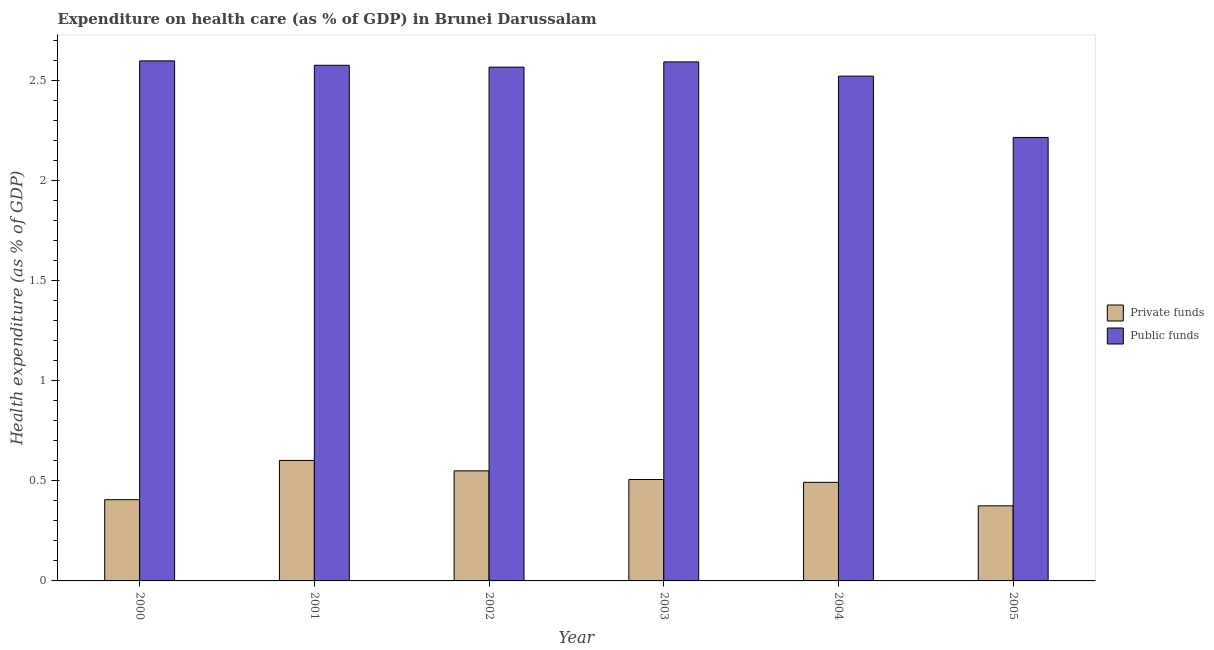In how many cases, is the number of bars for a given year not equal to the number of legend labels?
Offer a terse response. 0. What is the amount of private funds spent in healthcare in 2001?
Make the answer very short. 0.6. Across all years, what is the maximum amount of private funds spent in healthcare?
Your answer should be very brief. 0.6. Across all years, what is the minimum amount of private funds spent in healthcare?
Provide a short and direct response. 0.38. In which year was the amount of public funds spent in healthcare maximum?
Keep it short and to the point. 2000. In which year was the amount of public funds spent in healthcare minimum?
Give a very brief answer. 2005. What is the total amount of public funds spent in healthcare in the graph?
Ensure brevity in your answer.  15.07. What is the difference between the amount of private funds spent in healthcare in 2002 and that in 2003?
Offer a terse response. 0.04. What is the difference between the amount of public funds spent in healthcare in 2003 and the amount of private funds spent in healthcare in 2005?
Provide a succinct answer. 0.38. What is the average amount of public funds spent in healthcare per year?
Ensure brevity in your answer.  2.51. In how many years, is the amount of public funds spent in healthcare greater than 2.1 %?
Your answer should be very brief. 6. What is the ratio of the amount of private funds spent in healthcare in 2001 to that in 2004?
Offer a very short reply. 1.22. Is the difference between the amount of public funds spent in healthcare in 2003 and 2005 greater than the difference between the amount of private funds spent in healthcare in 2003 and 2005?
Your answer should be very brief. No. What is the difference between the highest and the second highest amount of public funds spent in healthcare?
Keep it short and to the point. 0.01. What is the difference between the highest and the lowest amount of public funds spent in healthcare?
Provide a succinct answer. 0.38. What does the 2nd bar from the left in 2000 represents?
Give a very brief answer. Public funds. What does the 1st bar from the right in 2001 represents?
Your response must be concise. Public funds. How many bars are there?
Make the answer very short. 12. What is the difference between two consecutive major ticks on the Y-axis?
Give a very brief answer. 0.5. Where does the legend appear in the graph?
Your answer should be very brief. Center right. How many legend labels are there?
Your answer should be very brief. 2. What is the title of the graph?
Your answer should be compact. Expenditure on health care (as % of GDP) in Brunei Darussalam. Does "By country of asylum" appear as one of the legend labels in the graph?
Keep it short and to the point. No. What is the label or title of the Y-axis?
Ensure brevity in your answer.  Health expenditure (as % of GDP). What is the Health expenditure (as % of GDP) in Private funds in 2000?
Offer a very short reply. 0.41. What is the Health expenditure (as % of GDP) in Public funds in 2000?
Keep it short and to the point. 2.6. What is the Health expenditure (as % of GDP) in Private funds in 2001?
Your answer should be very brief. 0.6. What is the Health expenditure (as % of GDP) in Public funds in 2001?
Offer a very short reply. 2.58. What is the Health expenditure (as % of GDP) of Private funds in 2002?
Your answer should be very brief. 0.55. What is the Health expenditure (as % of GDP) of Public funds in 2002?
Your answer should be compact. 2.57. What is the Health expenditure (as % of GDP) in Private funds in 2003?
Your answer should be very brief. 0.51. What is the Health expenditure (as % of GDP) of Public funds in 2003?
Provide a short and direct response. 2.59. What is the Health expenditure (as % of GDP) of Private funds in 2004?
Your answer should be compact. 0.49. What is the Health expenditure (as % of GDP) of Public funds in 2004?
Provide a short and direct response. 2.52. What is the Health expenditure (as % of GDP) of Private funds in 2005?
Keep it short and to the point. 0.38. What is the Health expenditure (as % of GDP) in Public funds in 2005?
Provide a short and direct response. 2.22. Across all years, what is the maximum Health expenditure (as % of GDP) of Private funds?
Your answer should be very brief. 0.6. Across all years, what is the maximum Health expenditure (as % of GDP) of Public funds?
Give a very brief answer. 2.6. Across all years, what is the minimum Health expenditure (as % of GDP) in Private funds?
Give a very brief answer. 0.38. Across all years, what is the minimum Health expenditure (as % of GDP) in Public funds?
Provide a succinct answer. 2.22. What is the total Health expenditure (as % of GDP) in Private funds in the graph?
Make the answer very short. 2.93. What is the total Health expenditure (as % of GDP) in Public funds in the graph?
Offer a terse response. 15.07. What is the difference between the Health expenditure (as % of GDP) of Private funds in 2000 and that in 2001?
Your response must be concise. -0.2. What is the difference between the Health expenditure (as % of GDP) in Public funds in 2000 and that in 2001?
Your response must be concise. 0.02. What is the difference between the Health expenditure (as % of GDP) of Private funds in 2000 and that in 2002?
Make the answer very short. -0.14. What is the difference between the Health expenditure (as % of GDP) of Public funds in 2000 and that in 2002?
Your answer should be compact. 0.03. What is the difference between the Health expenditure (as % of GDP) of Private funds in 2000 and that in 2003?
Provide a succinct answer. -0.1. What is the difference between the Health expenditure (as % of GDP) in Public funds in 2000 and that in 2003?
Provide a succinct answer. 0.01. What is the difference between the Health expenditure (as % of GDP) in Private funds in 2000 and that in 2004?
Keep it short and to the point. -0.09. What is the difference between the Health expenditure (as % of GDP) in Public funds in 2000 and that in 2004?
Your answer should be compact. 0.08. What is the difference between the Health expenditure (as % of GDP) of Private funds in 2000 and that in 2005?
Ensure brevity in your answer.  0.03. What is the difference between the Health expenditure (as % of GDP) in Public funds in 2000 and that in 2005?
Your answer should be very brief. 0.38. What is the difference between the Health expenditure (as % of GDP) of Private funds in 2001 and that in 2002?
Your answer should be compact. 0.05. What is the difference between the Health expenditure (as % of GDP) in Public funds in 2001 and that in 2002?
Your answer should be very brief. 0.01. What is the difference between the Health expenditure (as % of GDP) in Private funds in 2001 and that in 2003?
Offer a terse response. 0.1. What is the difference between the Health expenditure (as % of GDP) of Public funds in 2001 and that in 2003?
Offer a very short reply. -0.02. What is the difference between the Health expenditure (as % of GDP) of Private funds in 2001 and that in 2004?
Ensure brevity in your answer.  0.11. What is the difference between the Health expenditure (as % of GDP) of Public funds in 2001 and that in 2004?
Ensure brevity in your answer.  0.05. What is the difference between the Health expenditure (as % of GDP) in Private funds in 2001 and that in 2005?
Offer a terse response. 0.23. What is the difference between the Health expenditure (as % of GDP) in Public funds in 2001 and that in 2005?
Ensure brevity in your answer.  0.36. What is the difference between the Health expenditure (as % of GDP) in Private funds in 2002 and that in 2003?
Ensure brevity in your answer.  0.04. What is the difference between the Health expenditure (as % of GDP) in Public funds in 2002 and that in 2003?
Offer a terse response. -0.03. What is the difference between the Health expenditure (as % of GDP) in Private funds in 2002 and that in 2004?
Ensure brevity in your answer.  0.06. What is the difference between the Health expenditure (as % of GDP) of Public funds in 2002 and that in 2004?
Provide a succinct answer. 0.05. What is the difference between the Health expenditure (as % of GDP) of Private funds in 2002 and that in 2005?
Provide a succinct answer. 0.17. What is the difference between the Health expenditure (as % of GDP) in Public funds in 2002 and that in 2005?
Ensure brevity in your answer.  0.35. What is the difference between the Health expenditure (as % of GDP) in Private funds in 2003 and that in 2004?
Give a very brief answer. 0.01. What is the difference between the Health expenditure (as % of GDP) of Public funds in 2003 and that in 2004?
Your answer should be very brief. 0.07. What is the difference between the Health expenditure (as % of GDP) of Private funds in 2003 and that in 2005?
Keep it short and to the point. 0.13. What is the difference between the Health expenditure (as % of GDP) of Public funds in 2003 and that in 2005?
Provide a short and direct response. 0.38. What is the difference between the Health expenditure (as % of GDP) of Private funds in 2004 and that in 2005?
Your answer should be very brief. 0.12. What is the difference between the Health expenditure (as % of GDP) in Public funds in 2004 and that in 2005?
Ensure brevity in your answer.  0.31. What is the difference between the Health expenditure (as % of GDP) of Private funds in 2000 and the Health expenditure (as % of GDP) of Public funds in 2001?
Your answer should be very brief. -2.17. What is the difference between the Health expenditure (as % of GDP) of Private funds in 2000 and the Health expenditure (as % of GDP) of Public funds in 2002?
Ensure brevity in your answer.  -2.16. What is the difference between the Health expenditure (as % of GDP) in Private funds in 2000 and the Health expenditure (as % of GDP) in Public funds in 2003?
Your answer should be very brief. -2.19. What is the difference between the Health expenditure (as % of GDP) of Private funds in 2000 and the Health expenditure (as % of GDP) of Public funds in 2004?
Your response must be concise. -2.12. What is the difference between the Health expenditure (as % of GDP) in Private funds in 2000 and the Health expenditure (as % of GDP) in Public funds in 2005?
Make the answer very short. -1.81. What is the difference between the Health expenditure (as % of GDP) in Private funds in 2001 and the Health expenditure (as % of GDP) in Public funds in 2002?
Provide a succinct answer. -1.97. What is the difference between the Health expenditure (as % of GDP) in Private funds in 2001 and the Health expenditure (as % of GDP) in Public funds in 2003?
Offer a terse response. -1.99. What is the difference between the Health expenditure (as % of GDP) of Private funds in 2001 and the Health expenditure (as % of GDP) of Public funds in 2004?
Your answer should be compact. -1.92. What is the difference between the Health expenditure (as % of GDP) of Private funds in 2001 and the Health expenditure (as % of GDP) of Public funds in 2005?
Your answer should be very brief. -1.61. What is the difference between the Health expenditure (as % of GDP) in Private funds in 2002 and the Health expenditure (as % of GDP) in Public funds in 2003?
Give a very brief answer. -2.04. What is the difference between the Health expenditure (as % of GDP) in Private funds in 2002 and the Health expenditure (as % of GDP) in Public funds in 2004?
Your answer should be very brief. -1.97. What is the difference between the Health expenditure (as % of GDP) of Private funds in 2002 and the Health expenditure (as % of GDP) of Public funds in 2005?
Offer a terse response. -1.67. What is the difference between the Health expenditure (as % of GDP) of Private funds in 2003 and the Health expenditure (as % of GDP) of Public funds in 2004?
Your answer should be compact. -2.02. What is the difference between the Health expenditure (as % of GDP) in Private funds in 2003 and the Health expenditure (as % of GDP) in Public funds in 2005?
Offer a terse response. -1.71. What is the difference between the Health expenditure (as % of GDP) of Private funds in 2004 and the Health expenditure (as % of GDP) of Public funds in 2005?
Offer a terse response. -1.72. What is the average Health expenditure (as % of GDP) of Private funds per year?
Your answer should be very brief. 0.49. What is the average Health expenditure (as % of GDP) of Public funds per year?
Make the answer very short. 2.51. In the year 2000, what is the difference between the Health expenditure (as % of GDP) in Private funds and Health expenditure (as % of GDP) in Public funds?
Make the answer very short. -2.19. In the year 2001, what is the difference between the Health expenditure (as % of GDP) of Private funds and Health expenditure (as % of GDP) of Public funds?
Keep it short and to the point. -1.97. In the year 2002, what is the difference between the Health expenditure (as % of GDP) of Private funds and Health expenditure (as % of GDP) of Public funds?
Your answer should be compact. -2.02. In the year 2003, what is the difference between the Health expenditure (as % of GDP) in Private funds and Health expenditure (as % of GDP) in Public funds?
Provide a succinct answer. -2.09. In the year 2004, what is the difference between the Health expenditure (as % of GDP) in Private funds and Health expenditure (as % of GDP) in Public funds?
Ensure brevity in your answer.  -2.03. In the year 2005, what is the difference between the Health expenditure (as % of GDP) in Private funds and Health expenditure (as % of GDP) in Public funds?
Offer a terse response. -1.84. What is the ratio of the Health expenditure (as % of GDP) in Private funds in 2000 to that in 2001?
Your answer should be very brief. 0.67. What is the ratio of the Health expenditure (as % of GDP) in Public funds in 2000 to that in 2001?
Your answer should be compact. 1.01. What is the ratio of the Health expenditure (as % of GDP) in Private funds in 2000 to that in 2002?
Your response must be concise. 0.74. What is the ratio of the Health expenditure (as % of GDP) in Public funds in 2000 to that in 2002?
Make the answer very short. 1.01. What is the ratio of the Health expenditure (as % of GDP) of Private funds in 2000 to that in 2003?
Your answer should be very brief. 0.8. What is the ratio of the Health expenditure (as % of GDP) of Private funds in 2000 to that in 2004?
Give a very brief answer. 0.82. What is the ratio of the Health expenditure (as % of GDP) in Public funds in 2000 to that in 2004?
Ensure brevity in your answer.  1.03. What is the ratio of the Health expenditure (as % of GDP) in Private funds in 2000 to that in 2005?
Your response must be concise. 1.08. What is the ratio of the Health expenditure (as % of GDP) in Public funds in 2000 to that in 2005?
Ensure brevity in your answer.  1.17. What is the ratio of the Health expenditure (as % of GDP) of Private funds in 2001 to that in 2002?
Ensure brevity in your answer.  1.09. What is the ratio of the Health expenditure (as % of GDP) of Private funds in 2001 to that in 2003?
Ensure brevity in your answer.  1.19. What is the ratio of the Health expenditure (as % of GDP) of Private funds in 2001 to that in 2004?
Your response must be concise. 1.22. What is the ratio of the Health expenditure (as % of GDP) of Public funds in 2001 to that in 2004?
Your response must be concise. 1.02. What is the ratio of the Health expenditure (as % of GDP) of Private funds in 2001 to that in 2005?
Give a very brief answer. 1.61. What is the ratio of the Health expenditure (as % of GDP) in Public funds in 2001 to that in 2005?
Make the answer very short. 1.16. What is the ratio of the Health expenditure (as % of GDP) in Private funds in 2002 to that in 2003?
Provide a succinct answer. 1.09. What is the ratio of the Health expenditure (as % of GDP) of Public funds in 2002 to that in 2003?
Offer a terse response. 0.99. What is the ratio of the Health expenditure (as % of GDP) of Private funds in 2002 to that in 2004?
Your answer should be compact. 1.12. What is the ratio of the Health expenditure (as % of GDP) of Public funds in 2002 to that in 2004?
Your answer should be compact. 1.02. What is the ratio of the Health expenditure (as % of GDP) in Private funds in 2002 to that in 2005?
Provide a succinct answer. 1.47. What is the ratio of the Health expenditure (as % of GDP) in Public funds in 2002 to that in 2005?
Provide a succinct answer. 1.16. What is the ratio of the Health expenditure (as % of GDP) in Private funds in 2003 to that in 2004?
Your answer should be compact. 1.03. What is the ratio of the Health expenditure (as % of GDP) in Public funds in 2003 to that in 2004?
Give a very brief answer. 1.03. What is the ratio of the Health expenditure (as % of GDP) of Private funds in 2003 to that in 2005?
Make the answer very short. 1.35. What is the ratio of the Health expenditure (as % of GDP) in Public funds in 2003 to that in 2005?
Your response must be concise. 1.17. What is the ratio of the Health expenditure (as % of GDP) in Private funds in 2004 to that in 2005?
Provide a succinct answer. 1.31. What is the ratio of the Health expenditure (as % of GDP) in Public funds in 2004 to that in 2005?
Offer a very short reply. 1.14. What is the difference between the highest and the second highest Health expenditure (as % of GDP) of Private funds?
Provide a succinct answer. 0.05. What is the difference between the highest and the second highest Health expenditure (as % of GDP) of Public funds?
Offer a terse response. 0.01. What is the difference between the highest and the lowest Health expenditure (as % of GDP) of Private funds?
Provide a succinct answer. 0.23. What is the difference between the highest and the lowest Health expenditure (as % of GDP) in Public funds?
Your response must be concise. 0.38. 